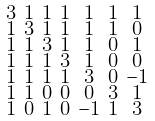<formula> <loc_0><loc_0><loc_500><loc_500>\begin{smallmatrix} 3 & 1 & 1 & 1 & 1 & 1 & 1 \\ 1 & 3 & 1 & 1 & 1 & 1 & 0 \\ 1 & 1 & 3 & 1 & 1 & 0 & 1 \\ 1 & 1 & 1 & 3 & 1 & 0 & 0 \\ 1 & 1 & 1 & 1 & 3 & 0 & - 1 \\ 1 & 1 & 0 & 0 & 0 & 3 & 1 \\ 1 & 0 & 1 & 0 & - 1 & 1 & 3 \end{smallmatrix}</formula> 